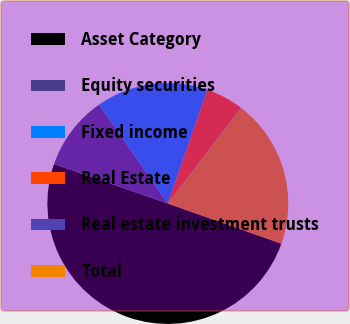Convert chart to OTSL. <chart><loc_0><loc_0><loc_500><loc_500><pie_chart><fcel>Asset Category<fcel>Equity securities<fcel>Fixed income<fcel>Real Estate<fcel>Real estate investment trusts<fcel>Total<nl><fcel>49.9%<fcel>10.02%<fcel>15.0%<fcel>5.03%<fcel>0.05%<fcel>19.99%<nl></chart> 